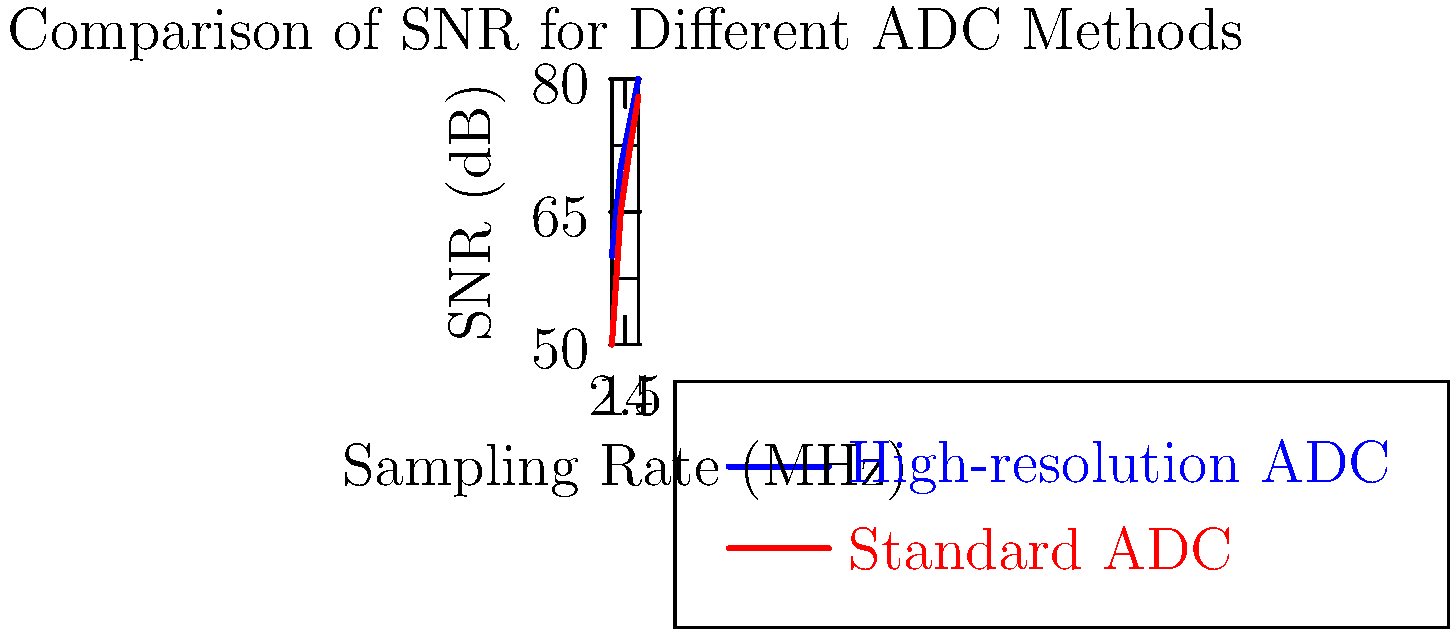In the context of digitizing analog audio recordings for archival purposes, which method consistently provides a higher signal-to-noise ratio (SNR) across various sampling rates, and by approximately how many decibels does it outperform the other method at 2 MHz? To answer this question, we need to analyze the graph and compare the two methods:

1. The blue line represents the high-resolution ADC (Analog-to-Digital Converter) method.
2. The red line represents the standard ADC method.

Step 1: Observe the overall trend
- The blue line (high-resolution ADC) is consistently higher than the red line (standard ADC) across all sampling rates.

Step 2: Compare the SNR values at 2 MHz
- At 2 MHz (x-axis value of 2):
  - High-resolution ADC (blue line): approximately 70 dB
  - Standard ADC (red line): approximately 65 dB

Step 3: Calculate the difference
- Difference = High-resolution ADC SNR - Standard ADC SNR
- Difference ≈ 70 dB - 65 dB = 5 dB

Therefore, the high-resolution ADC method consistently provides a higher SNR across various sampling rates, outperforming the standard ADC method by approximately 5 dB at 2 MHz.
Answer: High-resolution ADC, 5 dB 